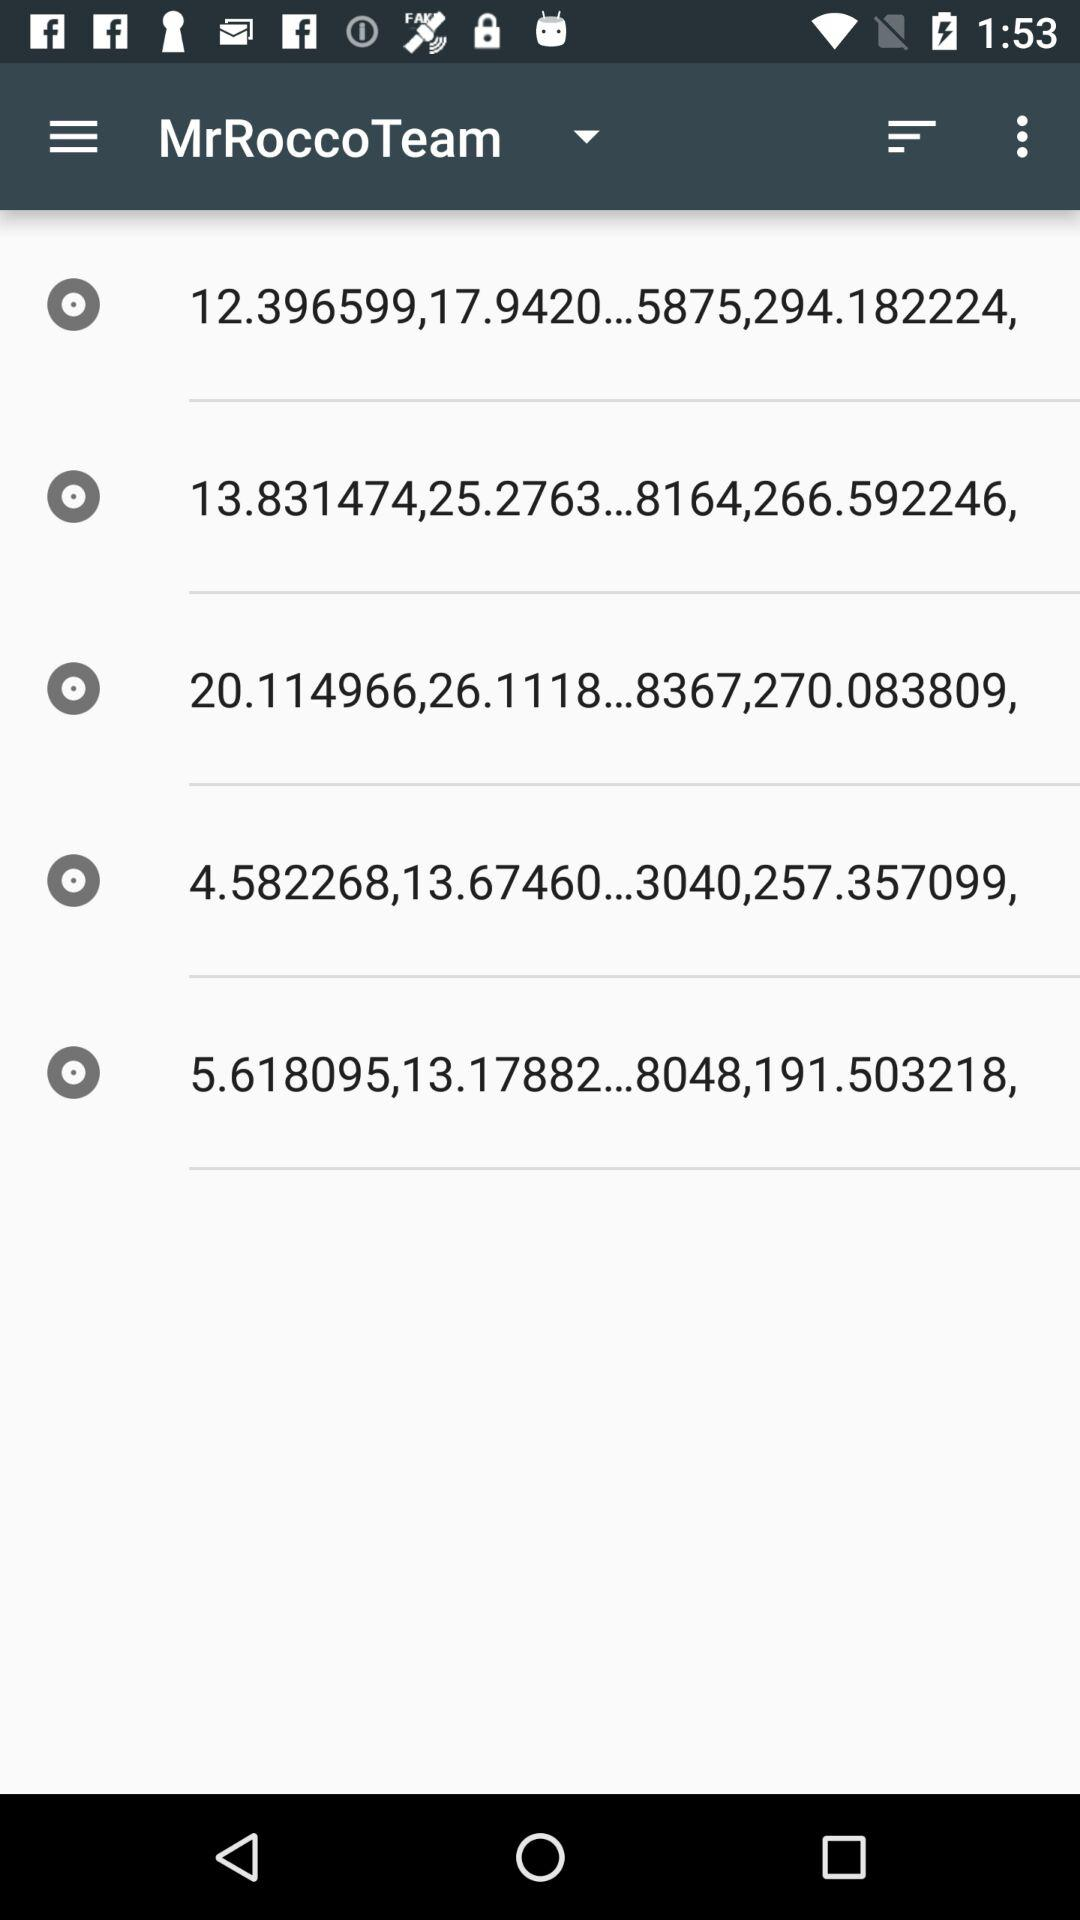What is the selected team name? The selected team name is "MrRoccoTeam". 